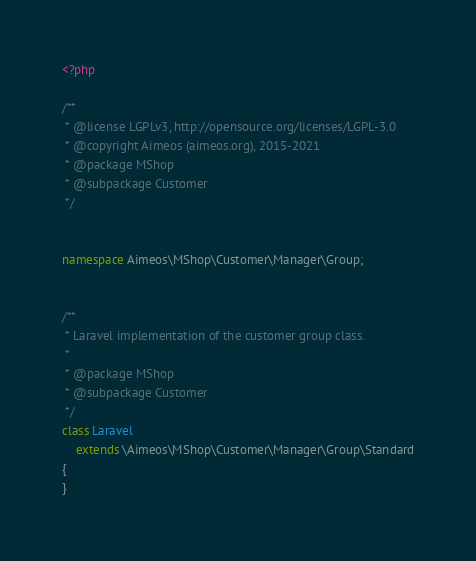Convert code to text. <code><loc_0><loc_0><loc_500><loc_500><_PHP_><?php

/**
 * @license LGPLv3, http://opensource.org/licenses/LGPL-3.0
 * @copyright Aimeos (aimeos.org), 2015-2021
 * @package MShop
 * @subpackage Customer
 */


namespace Aimeos\MShop\Customer\Manager\Group;


/**
 * Laravel implementation of the customer group class.
 *
 * @package MShop
 * @subpackage Customer
 */
class Laravel
	extends \Aimeos\MShop\Customer\Manager\Group\Standard
{
}
</code> 